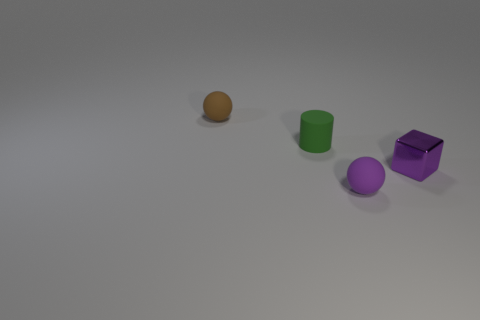Is the number of green rubber cylinders less than the number of small matte things?
Offer a terse response. Yes. There is a tiny ball to the left of the tiny matte ball in front of the brown object; what number of tiny rubber spheres are right of it?
Your response must be concise. 1. There is a purple object on the left side of the purple metal thing; what size is it?
Your answer should be compact. Small. There is a small rubber thing in front of the green rubber cylinder; is it the same shape as the small green rubber object?
Keep it short and to the point. No. There is another small object that is the same shape as the small brown rubber thing; what is its material?
Offer a terse response. Rubber. Are there any other things that have the same size as the brown rubber object?
Your answer should be compact. Yes. Are any brown shiny blocks visible?
Your answer should be compact. No. There is a ball to the right of the small sphere that is behind the tiny rubber ball that is on the right side of the brown matte ball; what is it made of?
Offer a terse response. Rubber. Is the shape of the green thing the same as the rubber thing behind the green cylinder?
Give a very brief answer. No. How many small purple things have the same shape as the tiny brown thing?
Keep it short and to the point. 1. 